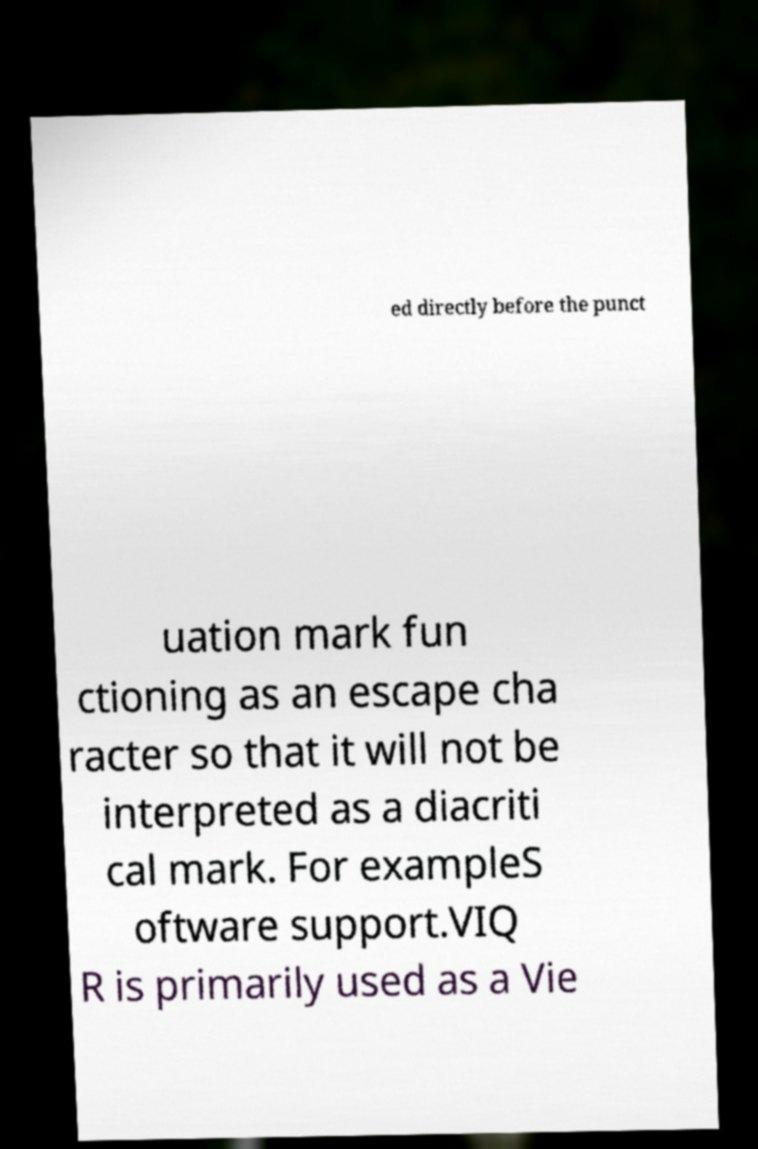Could you assist in decoding the text presented in this image and type it out clearly? ed directly before the punct uation mark fun ctioning as an escape cha racter so that it will not be interpreted as a diacriti cal mark. For exampleS oftware support.VIQ R is primarily used as a Vie 